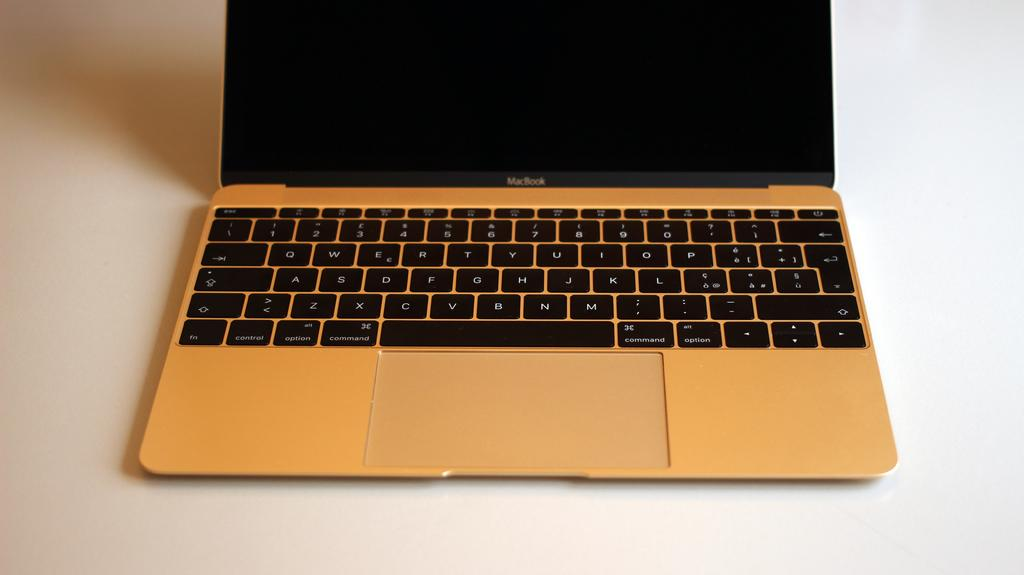<image>
Offer a succinct explanation of the picture presented. Macbook pro laptop with a black screen on a white surface. 